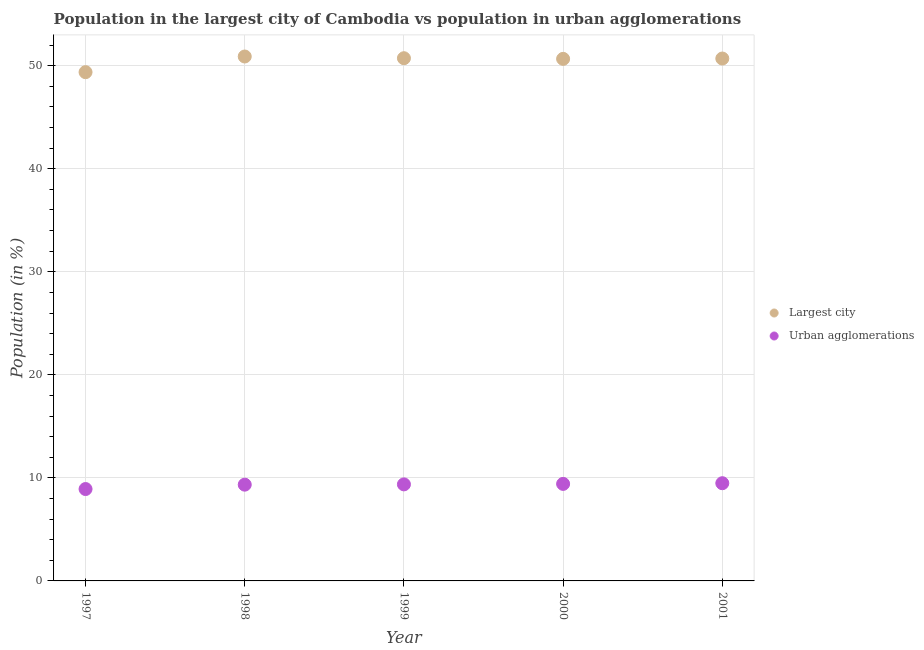How many different coloured dotlines are there?
Offer a terse response. 2. What is the population in the largest city in 1998?
Your answer should be very brief. 50.9. Across all years, what is the maximum population in the largest city?
Give a very brief answer. 50.9. Across all years, what is the minimum population in urban agglomerations?
Offer a terse response. 8.92. In which year was the population in the largest city minimum?
Keep it short and to the point. 1997. What is the total population in the largest city in the graph?
Your response must be concise. 252.38. What is the difference between the population in urban agglomerations in 2000 and that in 2001?
Keep it short and to the point. -0.07. What is the difference between the population in the largest city in 1997 and the population in urban agglomerations in 1999?
Your response must be concise. 40.01. What is the average population in the largest city per year?
Your answer should be very brief. 50.48. In the year 1998, what is the difference between the population in urban agglomerations and population in the largest city?
Provide a short and direct response. -41.56. What is the ratio of the population in the largest city in 1998 to that in 2000?
Offer a very short reply. 1. Is the population in urban agglomerations in 1997 less than that in 1999?
Make the answer very short. Yes. What is the difference between the highest and the second highest population in urban agglomerations?
Offer a terse response. 0.07. What is the difference between the highest and the lowest population in urban agglomerations?
Offer a terse response. 0.56. In how many years, is the population in urban agglomerations greater than the average population in urban agglomerations taken over all years?
Offer a terse response. 4. Is the sum of the population in urban agglomerations in 1999 and 2000 greater than the maximum population in the largest city across all years?
Offer a very short reply. No. Does the population in urban agglomerations monotonically increase over the years?
Offer a very short reply. Yes. Is the population in the largest city strictly greater than the population in urban agglomerations over the years?
Make the answer very short. Yes. Are the values on the major ticks of Y-axis written in scientific E-notation?
Your answer should be very brief. No. Does the graph contain any zero values?
Give a very brief answer. No. Where does the legend appear in the graph?
Provide a succinct answer. Center right. How many legend labels are there?
Give a very brief answer. 2. What is the title of the graph?
Give a very brief answer. Population in the largest city of Cambodia vs population in urban agglomerations. Does "Foreign Liabilities" appear as one of the legend labels in the graph?
Provide a short and direct response. No. What is the label or title of the X-axis?
Make the answer very short. Year. What is the label or title of the Y-axis?
Ensure brevity in your answer.  Population (in %). What is the Population (in %) in Largest city in 1997?
Make the answer very short. 49.38. What is the Population (in %) of Urban agglomerations in 1997?
Provide a succinct answer. 8.92. What is the Population (in %) in Largest city in 1998?
Provide a short and direct response. 50.9. What is the Population (in %) of Urban agglomerations in 1998?
Ensure brevity in your answer.  9.34. What is the Population (in %) of Largest city in 1999?
Provide a succinct answer. 50.73. What is the Population (in %) of Urban agglomerations in 1999?
Your response must be concise. 9.37. What is the Population (in %) in Largest city in 2000?
Ensure brevity in your answer.  50.67. What is the Population (in %) of Urban agglomerations in 2000?
Ensure brevity in your answer.  9.42. What is the Population (in %) in Largest city in 2001?
Give a very brief answer. 50.7. What is the Population (in %) in Urban agglomerations in 2001?
Offer a terse response. 9.48. Across all years, what is the maximum Population (in %) in Largest city?
Your answer should be very brief. 50.9. Across all years, what is the maximum Population (in %) in Urban agglomerations?
Provide a short and direct response. 9.48. Across all years, what is the minimum Population (in %) in Largest city?
Give a very brief answer. 49.38. Across all years, what is the minimum Population (in %) in Urban agglomerations?
Provide a succinct answer. 8.92. What is the total Population (in %) of Largest city in the graph?
Give a very brief answer. 252.38. What is the total Population (in %) in Urban agglomerations in the graph?
Give a very brief answer. 46.53. What is the difference between the Population (in %) of Largest city in 1997 and that in 1998?
Offer a very short reply. -1.52. What is the difference between the Population (in %) in Urban agglomerations in 1997 and that in 1998?
Provide a short and direct response. -0.42. What is the difference between the Population (in %) of Largest city in 1997 and that in 1999?
Keep it short and to the point. -1.35. What is the difference between the Population (in %) of Urban agglomerations in 1997 and that in 1999?
Offer a very short reply. -0.45. What is the difference between the Population (in %) in Largest city in 1997 and that in 2000?
Keep it short and to the point. -1.29. What is the difference between the Population (in %) of Urban agglomerations in 1997 and that in 2000?
Provide a short and direct response. -0.5. What is the difference between the Population (in %) in Largest city in 1997 and that in 2001?
Ensure brevity in your answer.  -1.32. What is the difference between the Population (in %) in Urban agglomerations in 1997 and that in 2001?
Ensure brevity in your answer.  -0.56. What is the difference between the Population (in %) of Largest city in 1998 and that in 1999?
Provide a short and direct response. 0.17. What is the difference between the Population (in %) in Urban agglomerations in 1998 and that in 1999?
Give a very brief answer. -0.03. What is the difference between the Population (in %) of Largest city in 1998 and that in 2000?
Provide a succinct answer. 0.23. What is the difference between the Population (in %) in Urban agglomerations in 1998 and that in 2000?
Offer a very short reply. -0.07. What is the difference between the Population (in %) in Largest city in 1998 and that in 2001?
Your answer should be compact. 0.2. What is the difference between the Population (in %) of Urban agglomerations in 1998 and that in 2001?
Make the answer very short. -0.14. What is the difference between the Population (in %) of Largest city in 1999 and that in 2000?
Ensure brevity in your answer.  0.06. What is the difference between the Population (in %) of Urban agglomerations in 1999 and that in 2000?
Make the answer very short. -0.05. What is the difference between the Population (in %) in Largest city in 1999 and that in 2001?
Offer a very short reply. 0.03. What is the difference between the Population (in %) in Urban agglomerations in 1999 and that in 2001?
Offer a terse response. -0.11. What is the difference between the Population (in %) of Largest city in 2000 and that in 2001?
Make the answer very short. -0.03. What is the difference between the Population (in %) of Urban agglomerations in 2000 and that in 2001?
Give a very brief answer. -0.07. What is the difference between the Population (in %) in Largest city in 1997 and the Population (in %) in Urban agglomerations in 1998?
Give a very brief answer. 40.04. What is the difference between the Population (in %) of Largest city in 1997 and the Population (in %) of Urban agglomerations in 1999?
Your response must be concise. 40.01. What is the difference between the Population (in %) in Largest city in 1997 and the Population (in %) in Urban agglomerations in 2000?
Keep it short and to the point. 39.96. What is the difference between the Population (in %) of Largest city in 1997 and the Population (in %) of Urban agglomerations in 2001?
Provide a short and direct response. 39.9. What is the difference between the Population (in %) of Largest city in 1998 and the Population (in %) of Urban agglomerations in 1999?
Make the answer very short. 41.53. What is the difference between the Population (in %) in Largest city in 1998 and the Population (in %) in Urban agglomerations in 2000?
Ensure brevity in your answer.  41.48. What is the difference between the Population (in %) of Largest city in 1998 and the Population (in %) of Urban agglomerations in 2001?
Offer a very short reply. 41.41. What is the difference between the Population (in %) of Largest city in 1999 and the Population (in %) of Urban agglomerations in 2000?
Offer a very short reply. 41.31. What is the difference between the Population (in %) of Largest city in 1999 and the Population (in %) of Urban agglomerations in 2001?
Your answer should be compact. 41.25. What is the difference between the Population (in %) of Largest city in 2000 and the Population (in %) of Urban agglomerations in 2001?
Make the answer very short. 41.19. What is the average Population (in %) of Largest city per year?
Give a very brief answer. 50.48. What is the average Population (in %) of Urban agglomerations per year?
Keep it short and to the point. 9.31. In the year 1997, what is the difference between the Population (in %) of Largest city and Population (in %) of Urban agglomerations?
Ensure brevity in your answer.  40.46. In the year 1998, what is the difference between the Population (in %) of Largest city and Population (in %) of Urban agglomerations?
Offer a terse response. 41.56. In the year 1999, what is the difference between the Population (in %) in Largest city and Population (in %) in Urban agglomerations?
Ensure brevity in your answer.  41.36. In the year 2000, what is the difference between the Population (in %) of Largest city and Population (in %) of Urban agglomerations?
Ensure brevity in your answer.  41.25. In the year 2001, what is the difference between the Population (in %) in Largest city and Population (in %) in Urban agglomerations?
Give a very brief answer. 41.22. What is the ratio of the Population (in %) in Largest city in 1997 to that in 1998?
Provide a short and direct response. 0.97. What is the ratio of the Population (in %) of Urban agglomerations in 1997 to that in 1998?
Provide a succinct answer. 0.95. What is the ratio of the Population (in %) of Largest city in 1997 to that in 1999?
Provide a succinct answer. 0.97. What is the ratio of the Population (in %) of Urban agglomerations in 1997 to that in 1999?
Provide a succinct answer. 0.95. What is the ratio of the Population (in %) of Largest city in 1997 to that in 2000?
Offer a very short reply. 0.97. What is the ratio of the Population (in %) of Urban agglomerations in 1997 to that in 2000?
Your answer should be very brief. 0.95. What is the ratio of the Population (in %) of Largest city in 1997 to that in 2001?
Make the answer very short. 0.97. What is the ratio of the Population (in %) in Urban agglomerations in 1997 to that in 2001?
Offer a terse response. 0.94. What is the ratio of the Population (in %) in Largest city in 1998 to that in 1999?
Provide a short and direct response. 1. What is the ratio of the Population (in %) in Largest city in 1998 to that in 2000?
Your response must be concise. 1. What is the ratio of the Population (in %) in Urban agglomerations in 1998 to that in 2000?
Provide a short and direct response. 0.99. What is the ratio of the Population (in %) of Urban agglomerations in 1998 to that in 2001?
Your answer should be very brief. 0.99. What is the ratio of the Population (in %) in Urban agglomerations in 1999 to that in 2001?
Your response must be concise. 0.99. What is the ratio of the Population (in %) of Largest city in 2000 to that in 2001?
Provide a short and direct response. 1. What is the difference between the highest and the second highest Population (in %) in Largest city?
Your answer should be very brief. 0.17. What is the difference between the highest and the second highest Population (in %) of Urban agglomerations?
Offer a very short reply. 0.07. What is the difference between the highest and the lowest Population (in %) in Largest city?
Ensure brevity in your answer.  1.52. What is the difference between the highest and the lowest Population (in %) in Urban agglomerations?
Your answer should be very brief. 0.56. 